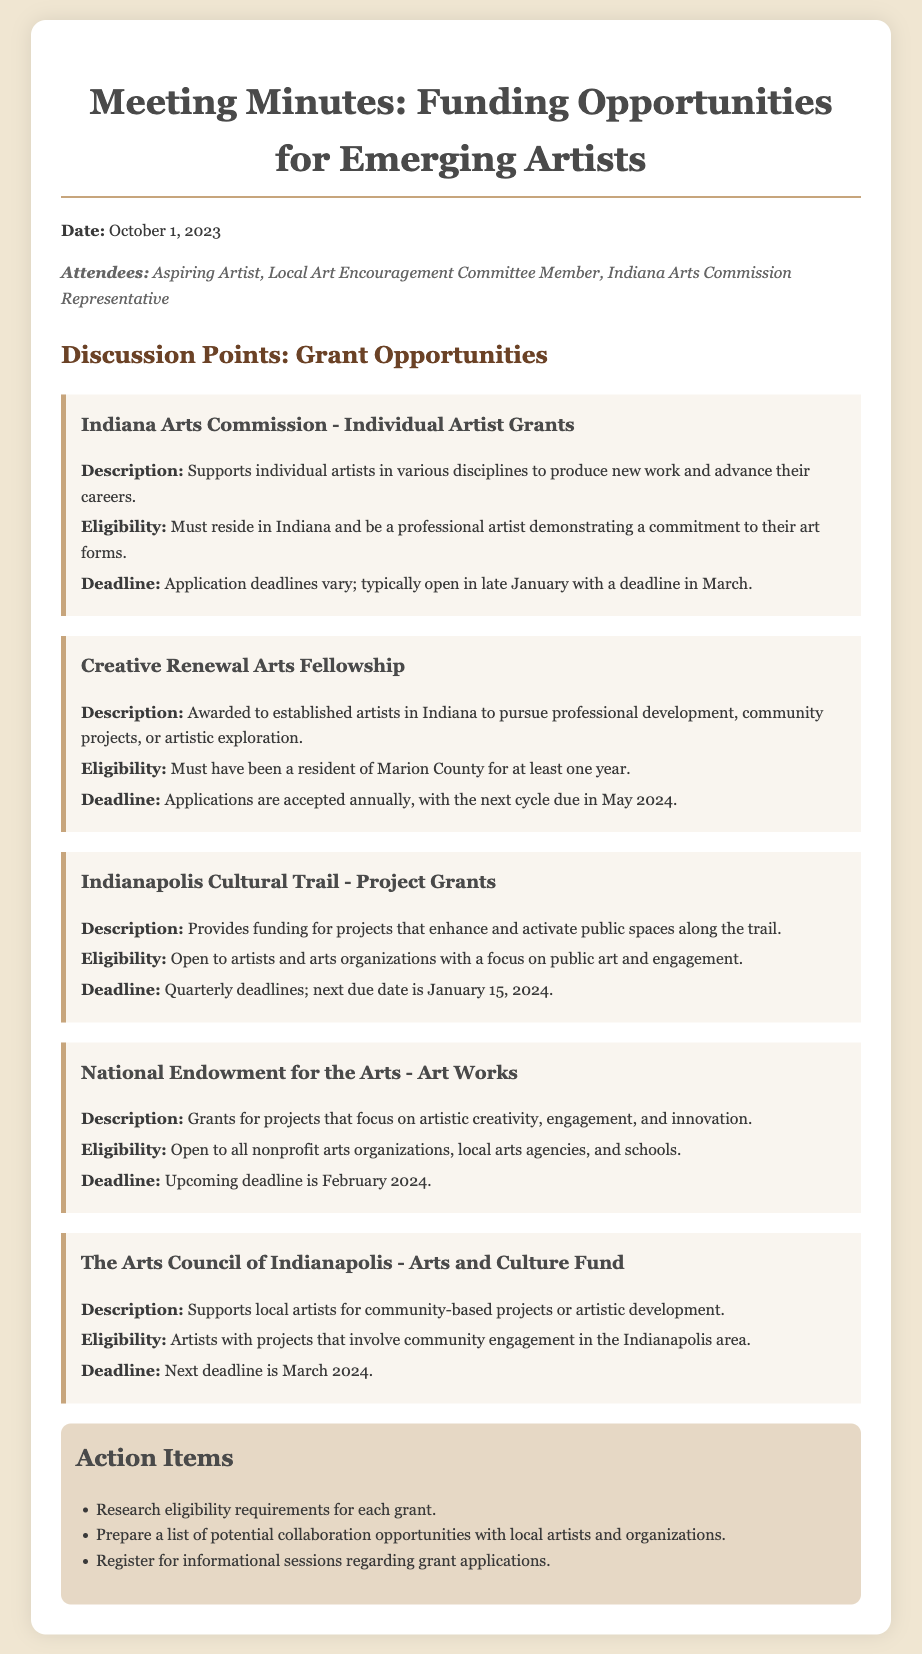what is the publication date of the meeting minutes? The publication date is clearly stated at the beginning of the document, which is October 1, 2023.
Answer: October 1, 2023 how many attendees are listed in the meeting? The number of attendees can be found in the attendees section, which lists three participants.
Answer: 3 what is the next application deadline for the Creative Renewal Arts Fellowship? The next application deadline is mentioned in the discussion of the fellowship, which states it is due in May 2024.
Answer: May 2024 who is eligible for the Indiana Arts Commission - Individual Artist Grants? The eligibility criteria are provided in the grant description, specifying that applicants must reside in Indiana and demonstrate a commitment to their art forms.
Answer: Must reside in Indiana and be a professional artist what type of projects does the Indianapolis Cultural Trail - Project Grants focus on? The focus area for the Indianapolis Cultural Trail grants is indicated in the project's description, which mentions enhancing and activating public spaces.
Answer: Public art and engagement how often are the Indianapolis Cultural Trail - Project Grants deadlines? The frequency of the application deadlines is indicated in the grant section, stating they have quarterly deadlines.
Answer: Quarterly which funding opportunity supports community-based projects in Indianapolis? The specific funding opportunity mentioned for supporting community-based projects is outlined in the Arts and Culture Fund description.
Answer: Arts and Culture Fund what is one action item listed in the meeting minutes? The action items section provides a list of tasks, and one example is the requirement to research eligibility requirements for each grant.
Answer: Research eligibility requirements what is the purpose of the National Endowment for the Arts - Art Works grants? The purpose of these grants is summarized in the description, which highlights support for projects focusing on artistic creativity, engagement, and innovation.
Answer: Artistic creativity, engagement, and innovation what is the deadline for the next application under the Arts Council of Indianapolis - Arts and Culture Fund? The next application deadline for this funding opportunity is specified in the document, which is March 2024.
Answer: March 2024 